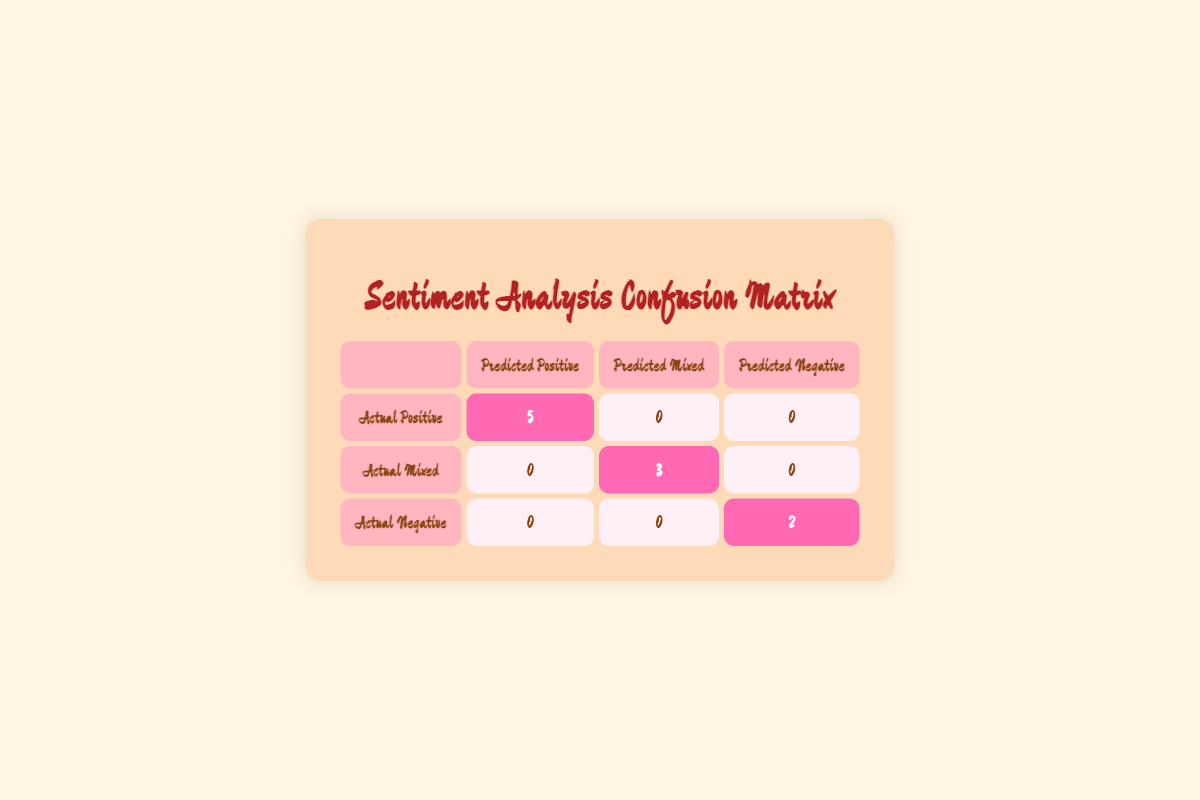What is the count of actual positive reviews predicted as positive? From the table, we can see that the count of actual positive reviews that have been predicted as positive is located at the intersection of "Actual Positive" and "Predicted Positive," which shows the value "5."
Answer: 5 How many actual mixed reviews were predicted as mixed? Looking at the table, the number of actual mixed reviews that were predicted as mixed is found at the intersection of "Actual Mixed" and "Predicted Mixed," which displays "3."
Answer: 3 Are there any actual negative reviews predicted as positive? By examining the table, we can see that there is a "0" in the cell where "Actual Negative" intersects with "Predicted Positive," indicating there are no actual negative reviews that are predicted as positive.
Answer: No What is the total number of reviews categorized as actual negative? To find the total number of actual negative reviews, we look at the entire row for "Actual Negative." The count there is just "2," meaning there are two reviews in total in the actual negative category.
Answer: 2 How many predicted mixed reviews correspond to actual positive reviews? In the table, the cell located at the intersection of "Actual Positive" and "Predicted Mixed" shows "0." This means that no actual positive reviews are categorized as predicted mixed.
Answer: 0 What is the total number of reviews that were classified as either positive or mixed? To find this, we sum the counts of "Actual Positive" and "Actual Mixed." This results in (5 + 3) = 8 reviews, which captures both categories' total.
Answer: 8 Is it true that all actual negative reviews were predicted as negative? Looking at the table at the intersection of "Actual Negative" and "Predicted Negative," we find the value "2." This shows all the actual negative reviews were predicted correctly as negative, confirming the statement is true.
Answer: Yes What percentage of actual positive reviews were correctly predicted? The number of actual positive reviews is 5, and all 5 were predicted as positive. To find the percentage, we calculate (5/5) * 100, giving us 100%.
Answer: 100% 